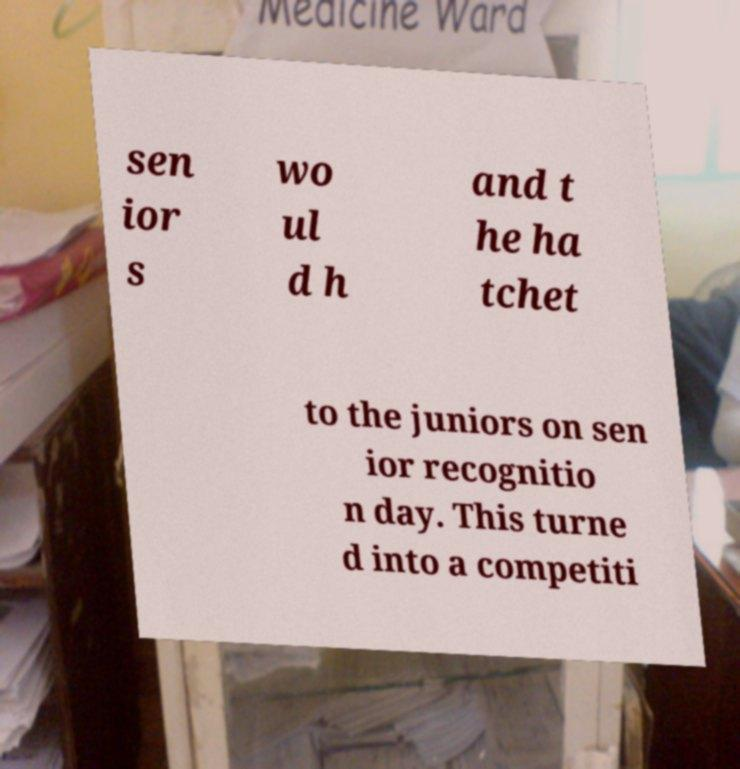I need the written content from this picture converted into text. Can you do that? sen ior s wo ul d h and t he ha tchet to the juniors on sen ior recognitio n day. This turne d into a competiti 